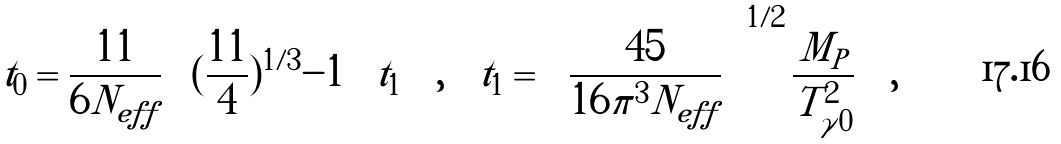<formula> <loc_0><loc_0><loc_500><loc_500>t _ { 0 } = \frac { 1 1 } { 6 N _ { e f f } } \left [ ( \frac { 1 1 } { 4 } ) ^ { 1 / 3 } - 1 \right ] t _ { 1 } \quad , \quad t _ { 1 } = \left [ \frac { 4 5 } { 1 6 \pi ^ { 3 } N _ { e f f } } \right ] ^ { 1 / 2 } \frac { M _ { P } } { T _ { \gamma 0 } ^ { 2 } } \quad ,</formula> 